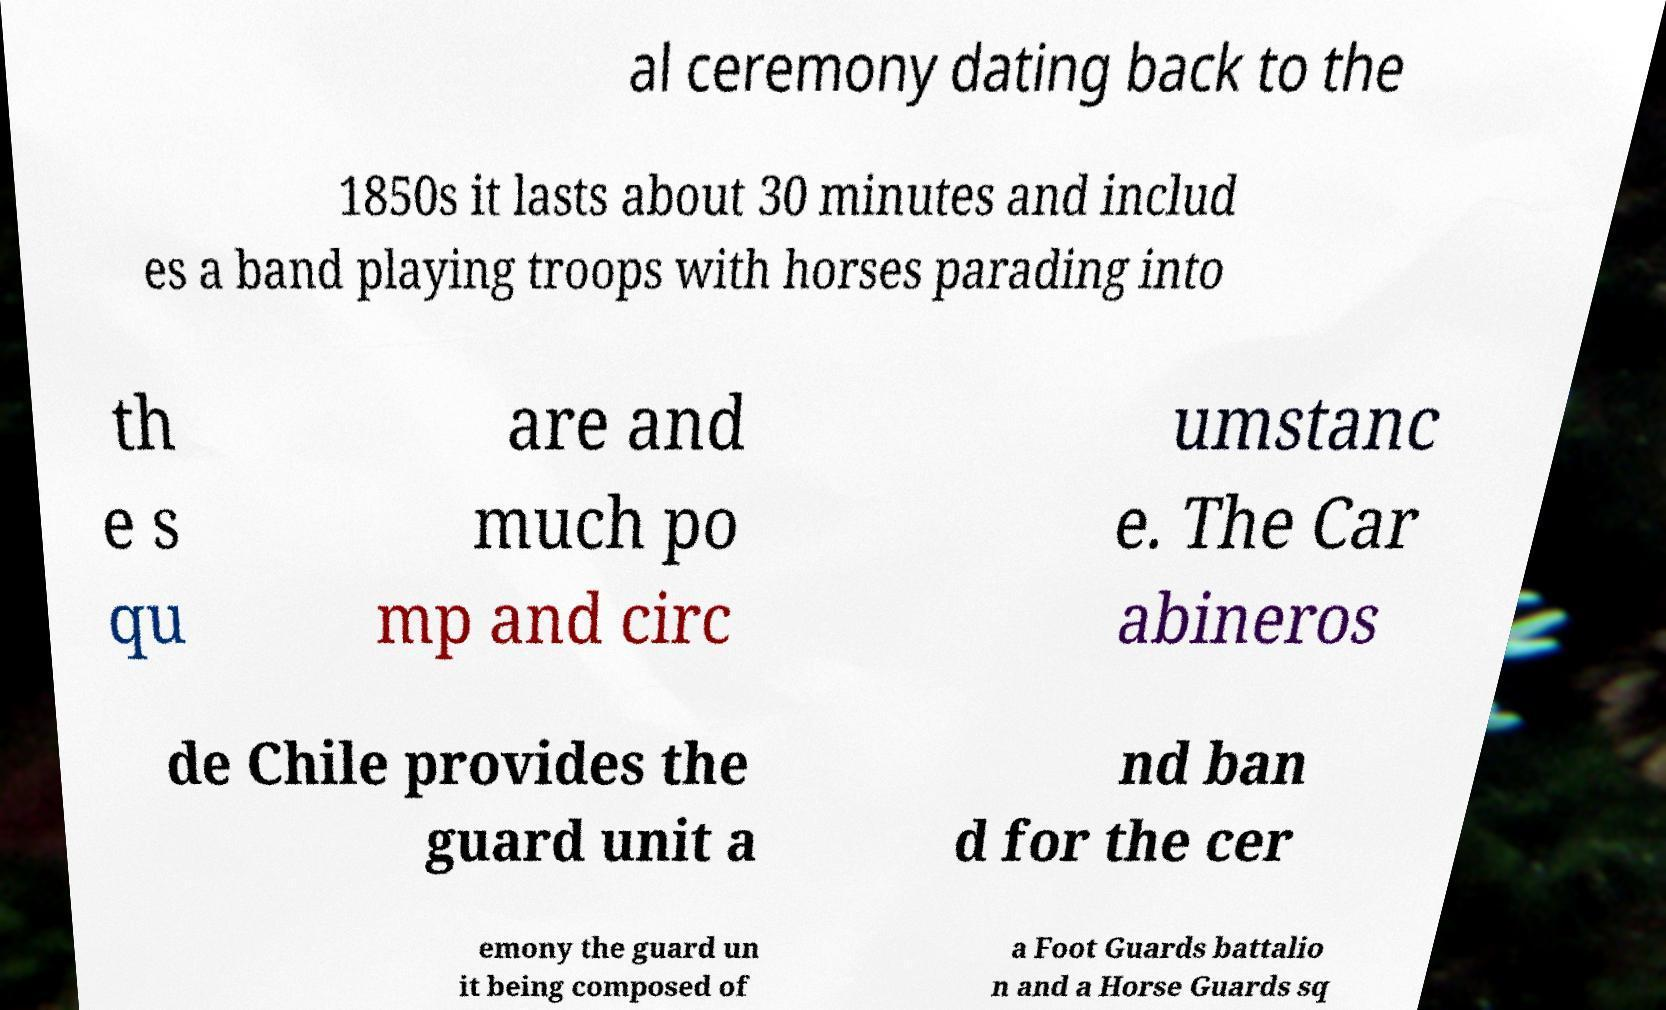For documentation purposes, I need the text within this image transcribed. Could you provide that? al ceremony dating back to the 1850s it lasts about 30 minutes and includ es a band playing troops with horses parading into th e s qu are and much po mp and circ umstanc e. The Car abineros de Chile provides the guard unit a nd ban d for the cer emony the guard un it being composed of a Foot Guards battalio n and a Horse Guards sq 